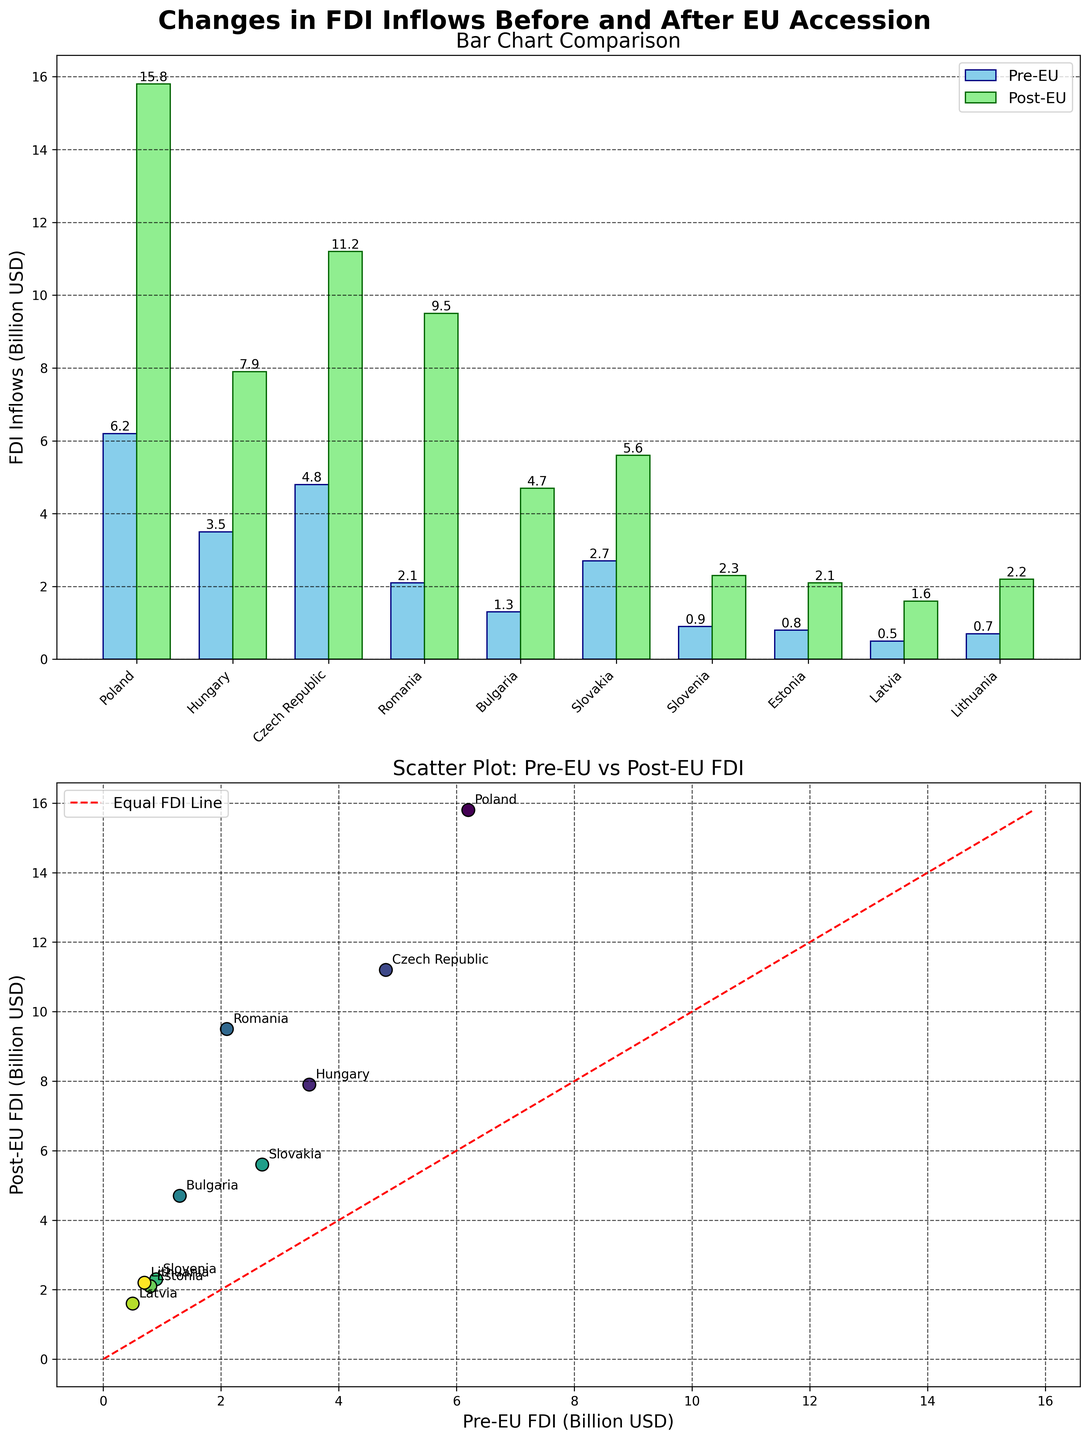What is the title of the figure? The title of the figure is located at the top center, usually in bold and large font. It provides a summary of what the figure represents.
Answer: Changes in FDI Inflows Before and After EU Accession How many countries are represented in the figure? Count the number of unique countries displayed on the x-axis in the bar chart or annotated in the scatter plot.
Answer: 10 Which country had the highest FDI inflows before EU accession? Identify the tallest bar in the Pre-EU (skyblue) section of the bar chart.
Answer: Poland Which country saw the greatest increase in FDI inflows following EU accession? Calculate the difference between Post-EU FDI and Pre-EU FDI for each country and find the maximum value.
Answer: Romania Compare the FDI inflows for Hungary before and after EU accession. Check the heights of the corresponding bars (one skyblue and one lightgreen) for Hungary in the bar chart.
Answer: Pre-EU: 3.5 Billion USD, Post-EU: 7.9 Billion USD Which countries had FDI inflows less than 1 billion USD before EU accession? Identify countries in the bar chart where the skyblue bars are below the 1-billion mark on the y-axis.
Answer: Estonia, Latvia, Lithuania, Slovenia What is the trend observed in the scatter plot regarding FDI inflows before and after EU accession? Analyze the general position of points relative to the red dashed line (Equal FDI Line) in the scatter plot.
Answer: Post-EU FDI inflows are generally higher Estimate the average FDI inflow before EU accession across all countries. Sum all Pre-EU FDI values and divide by the number of countries. Calculation: (6.2 + 3.5 + 4.8 + 2.1 + 1.3 + 2.7 + 0.9 + 0.8 + 0.5 + 0.7)/10
Answer: 2.75 Billion USD Which country is closest to the Equal FDI Line in the scatter plot, and what does this indicate? Measure the distance of each point from the red dashed line, finding the point that is closest. This indicates minor change in FDI inflows before and after EU accession.
Answer: Slovakia 